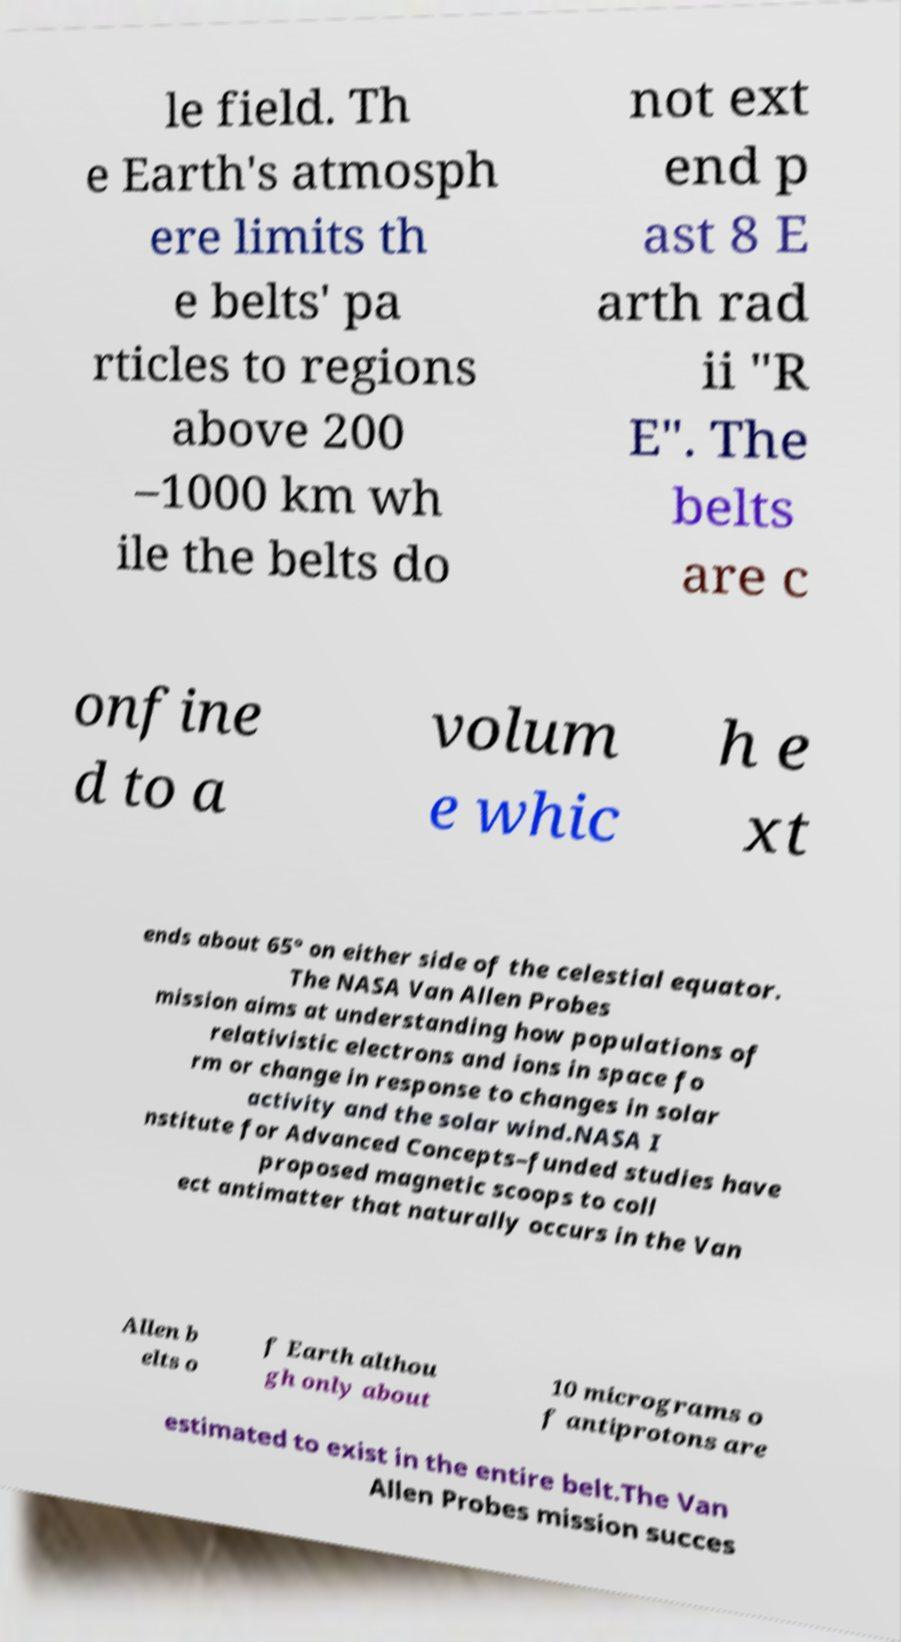There's text embedded in this image that I need extracted. Can you transcribe it verbatim? le field. Th e Earth's atmosph ere limits th e belts' pa rticles to regions above 200 –1000 km wh ile the belts do not ext end p ast 8 E arth rad ii "R E". The belts are c onfine d to a volum e whic h e xt ends about 65° on either side of the celestial equator. The NASA Van Allen Probes mission aims at understanding how populations of relativistic electrons and ions in space fo rm or change in response to changes in solar activity and the solar wind.NASA I nstitute for Advanced Concepts–funded studies have proposed magnetic scoops to coll ect antimatter that naturally occurs in the Van Allen b elts o f Earth althou gh only about 10 micrograms o f antiprotons are estimated to exist in the entire belt.The Van Allen Probes mission succes 